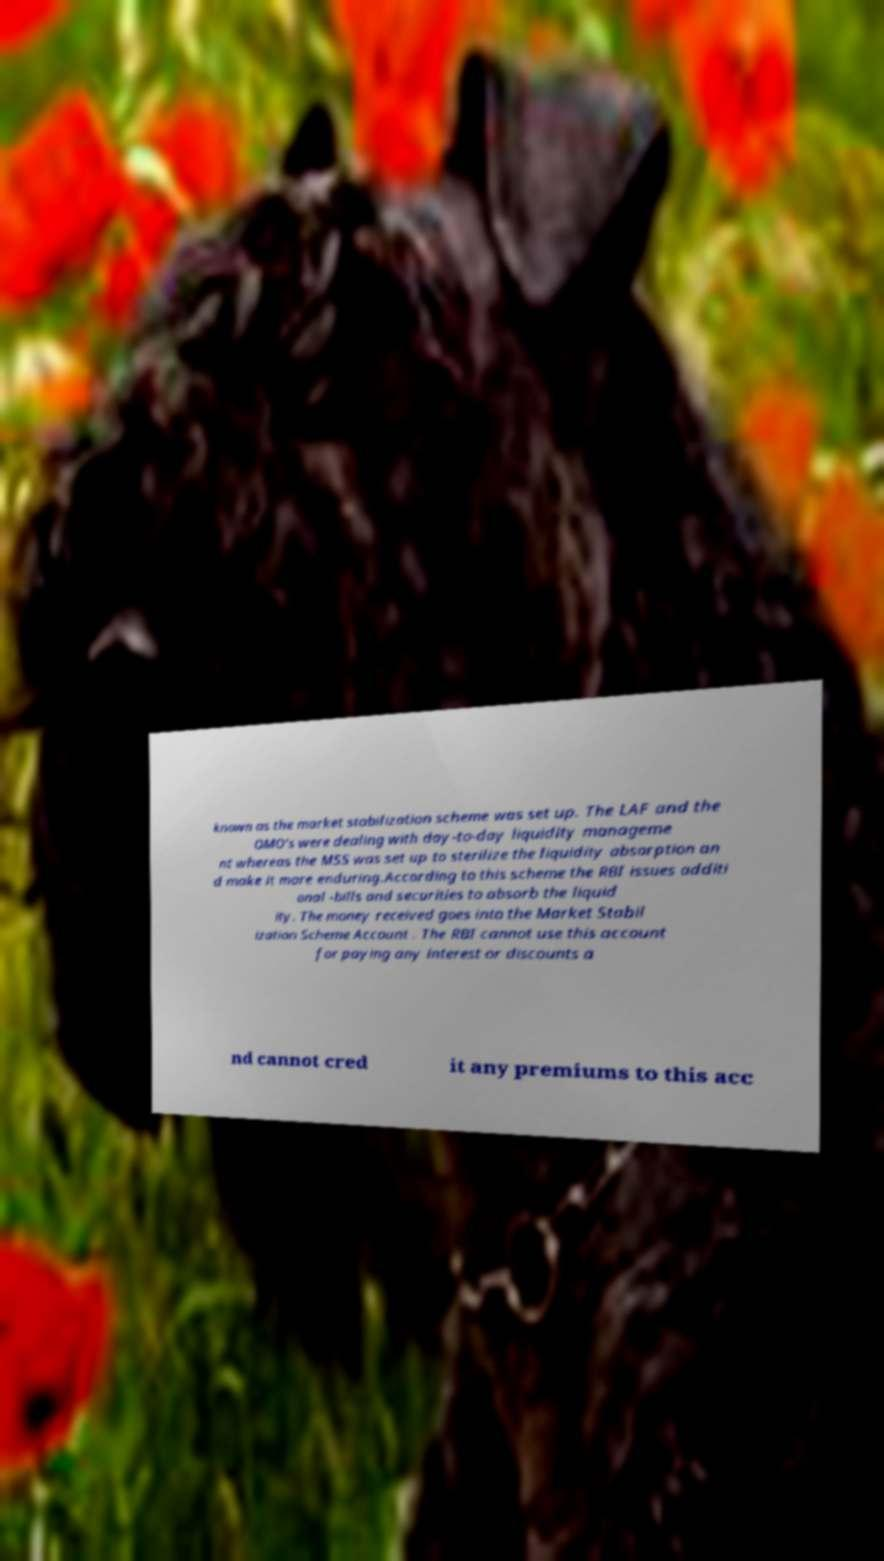Please read and relay the text visible in this image. What does it say? known as the market stabilization scheme was set up. The LAF and the OMO's were dealing with day-to-day liquidity manageme nt whereas the MSS was set up to sterilize the liquidity absorption an d make it more enduring.According to this scheme the RBI issues additi onal -bills and securities to absorb the liquid ity. The money received goes into the Market Stabil ization Scheme Account . The RBI cannot use this account for paying any interest or discounts a nd cannot cred it any premiums to this acc 